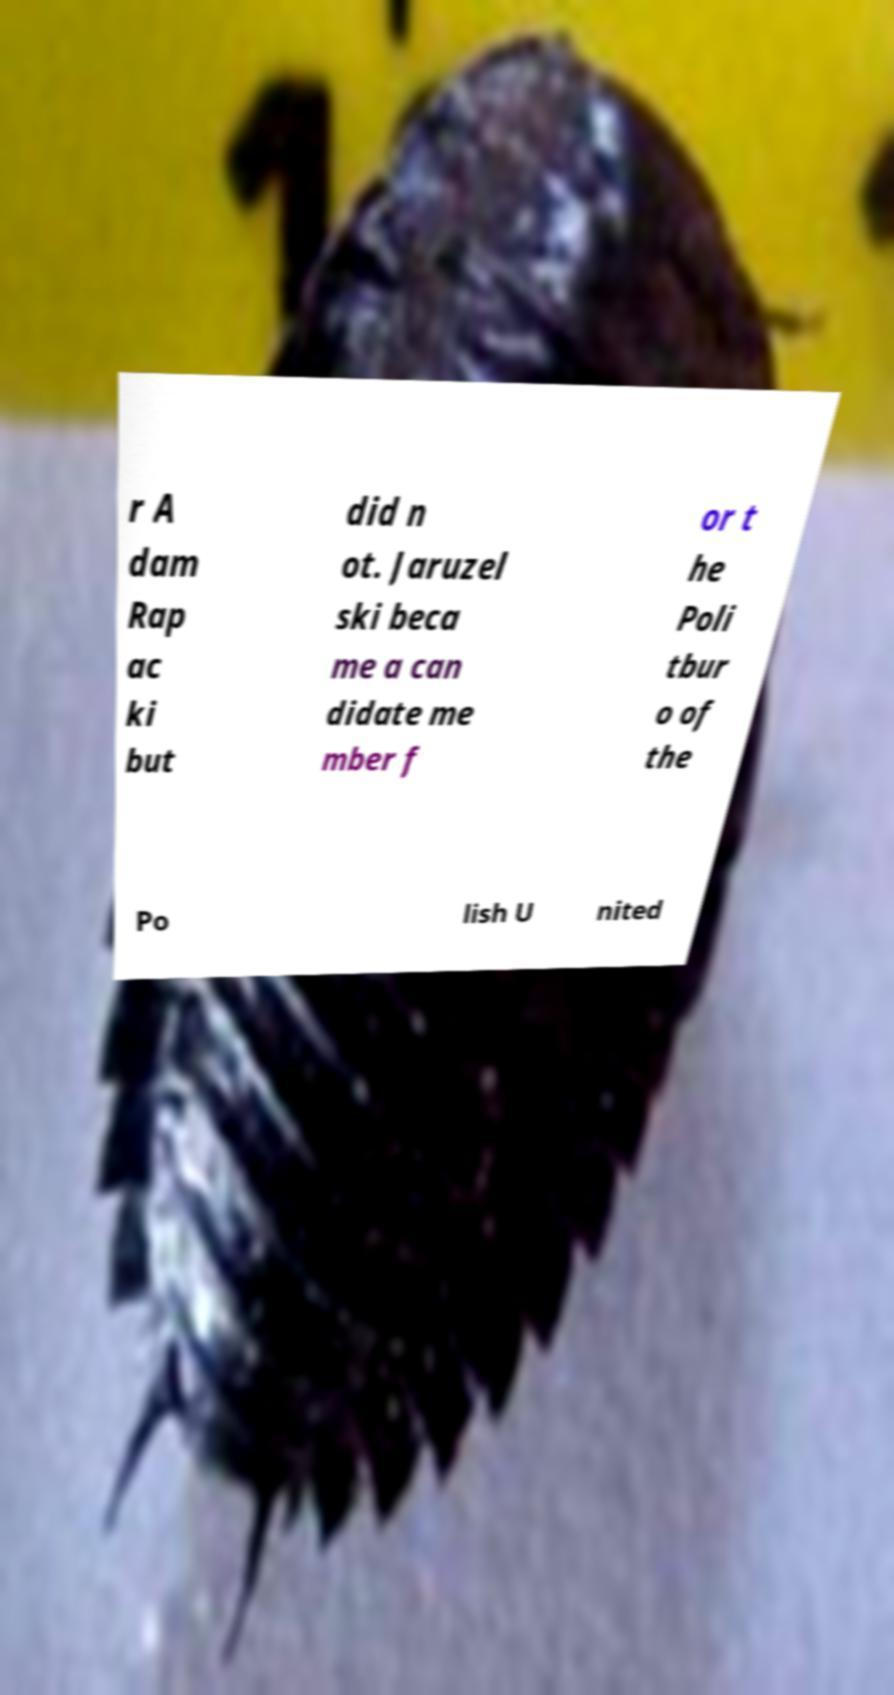There's text embedded in this image that I need extracted. Can you transcribe it verbatim? r A dam Rap ac ki but did n ot. Jaruzel ski beca me a can didate me mber f or t he Poli tbur o of the Po lish U nited 